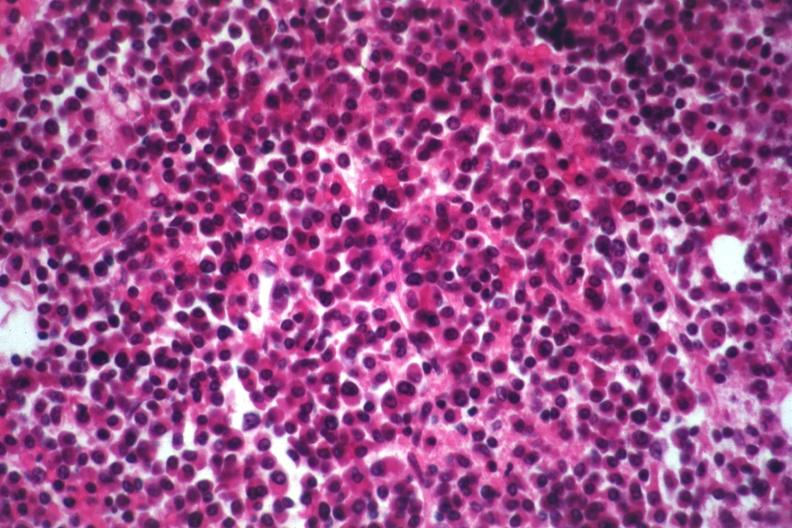s multiple myeloma present?
Answer the question using a single word or phrase. Yes 